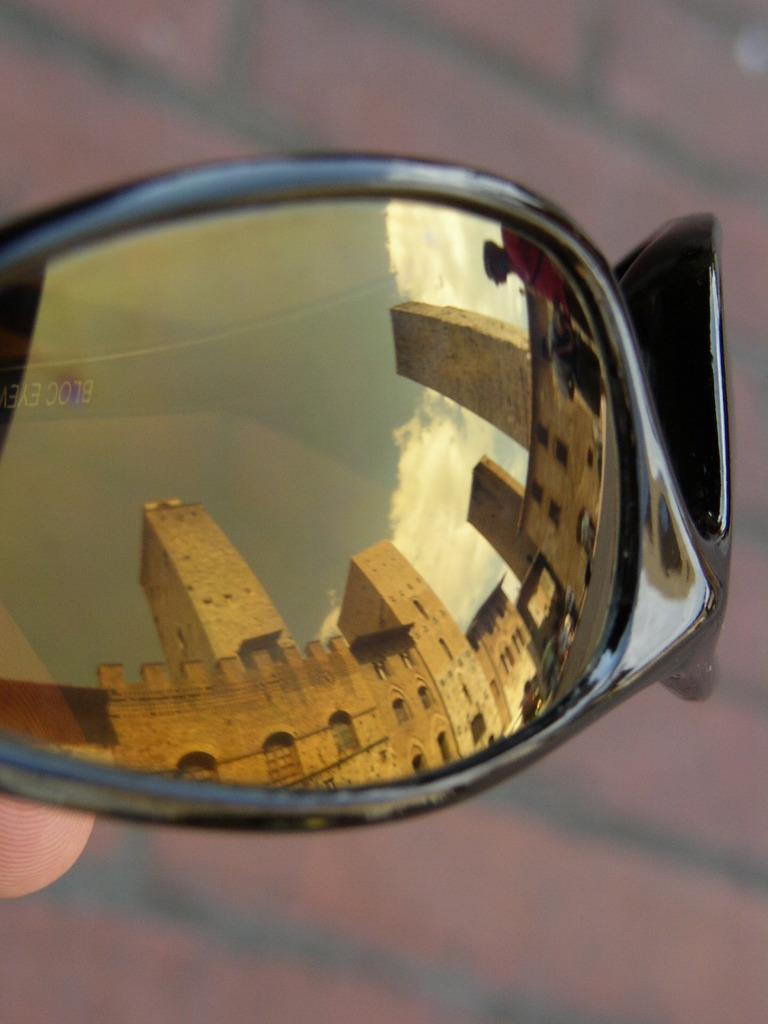What object is present in the image that can create reflections? There is a mirror in the image. What can be seen in the reflection of the mirror? The mirror reflects buildings. What type of instrument is being played by the brothers in the image? There are no brothers or instruments present in the image; it only features a mirror reflecting buildings. 